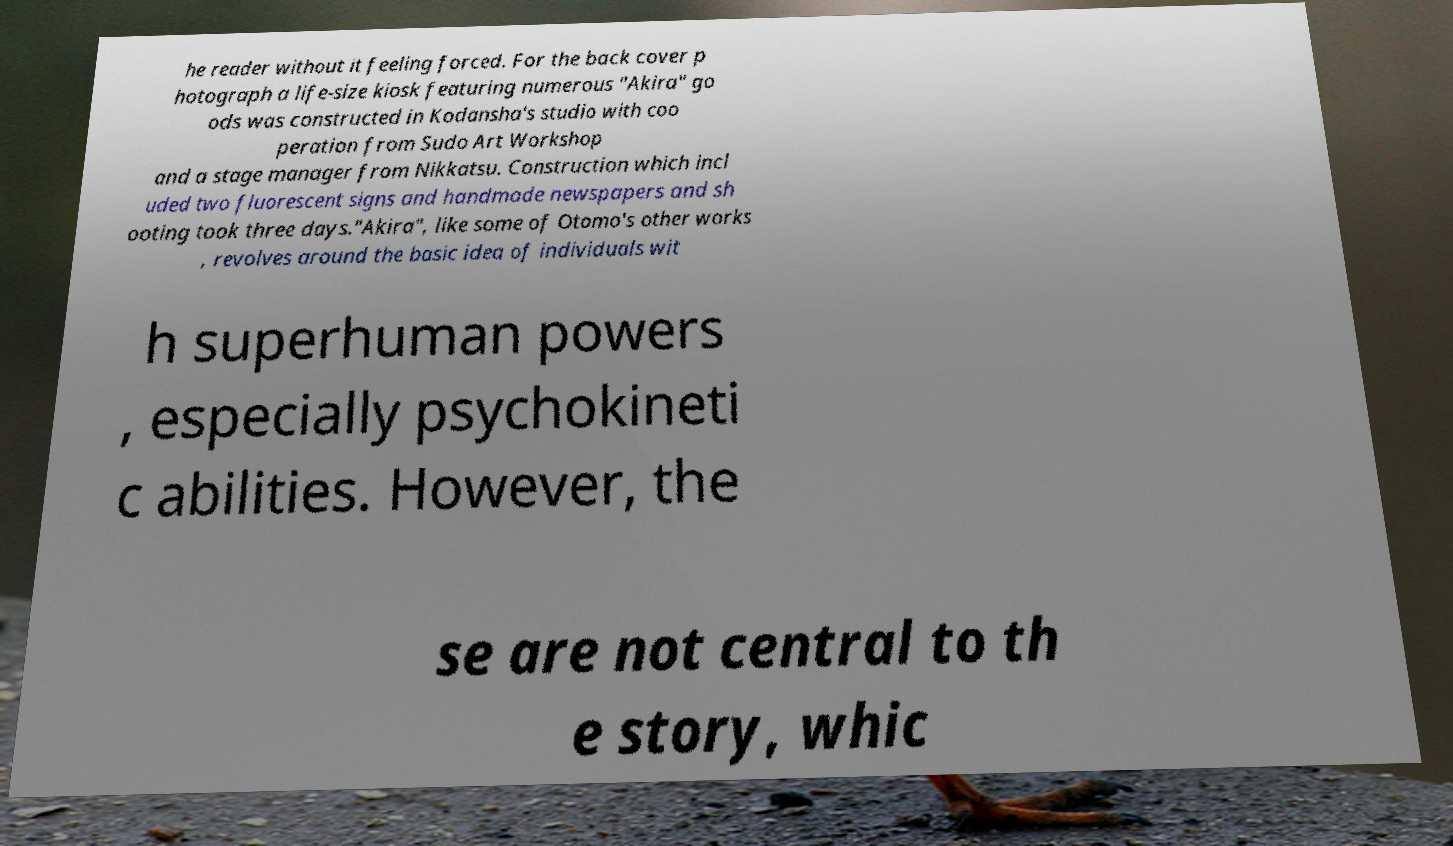For documentation purposes, I need the text within this image transcribed. Could you provide that? he reader without it feeling forced. For the back cover p hotograph a life-size kiosk featuring numerous "Akira" go ods was constructed in Kodansha's studio with coo peration from Sudo Art Workshop and a stage manager from Nikkatsu. Construction which incl uded two fluorescent signs and handmade newspapers and sh ooting took three days."Akira", like some of Otomo's other works , revolves around the basic idea of individuals wit h superhuman powers , especially psychokineti c abilities. However, the se are not central to th e story, whic 